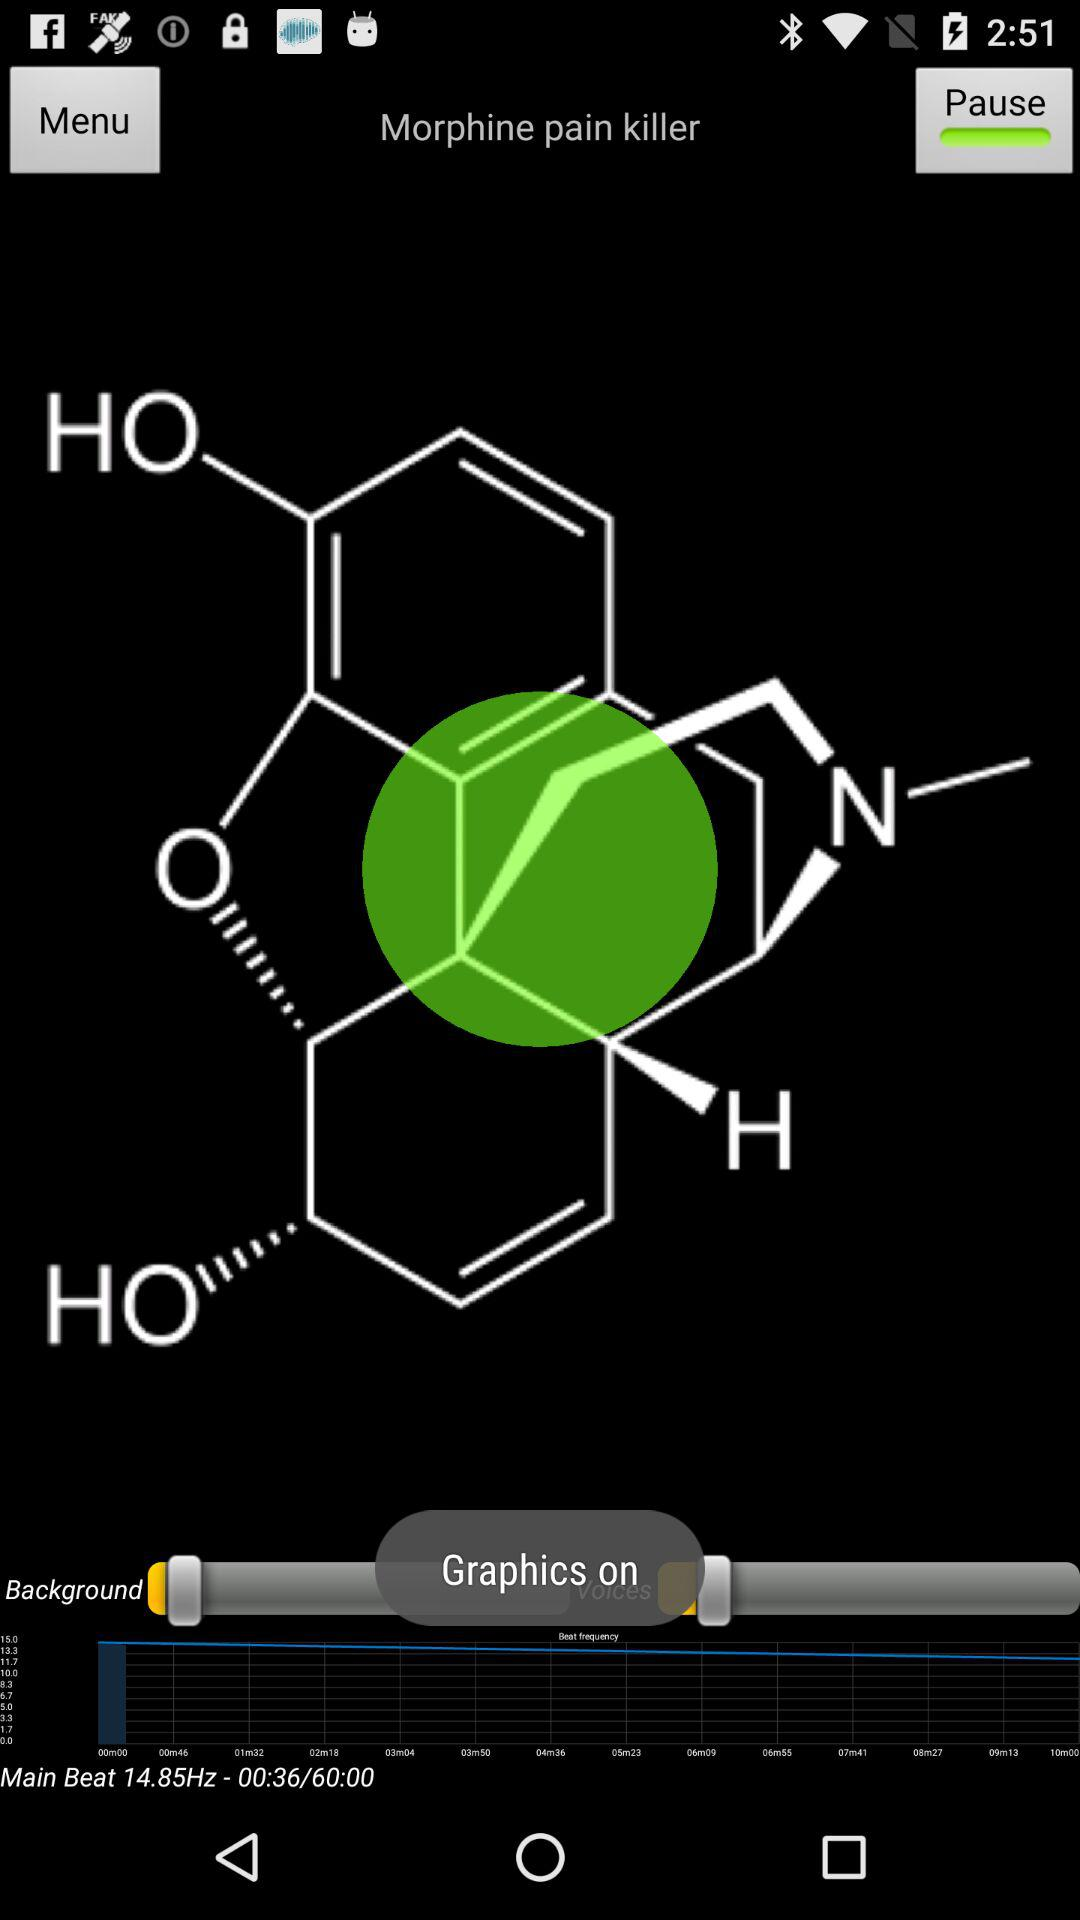What is morphine? Morphine is a pain killer. 